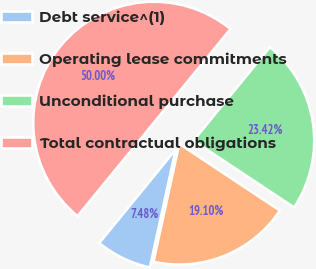Convert chart. <chart><loc_0><loc_0><loc_500><loc_500><pie_chart><fcel>Debt service^(1)<fcel>Operating lease commitments<fcel>Unconditional purchase<fcel>Total contractual obligations<nl><fcel>7.48%<fcel>19.1%<fcel>23.42%<fcel>50.0%<nl></chart> 